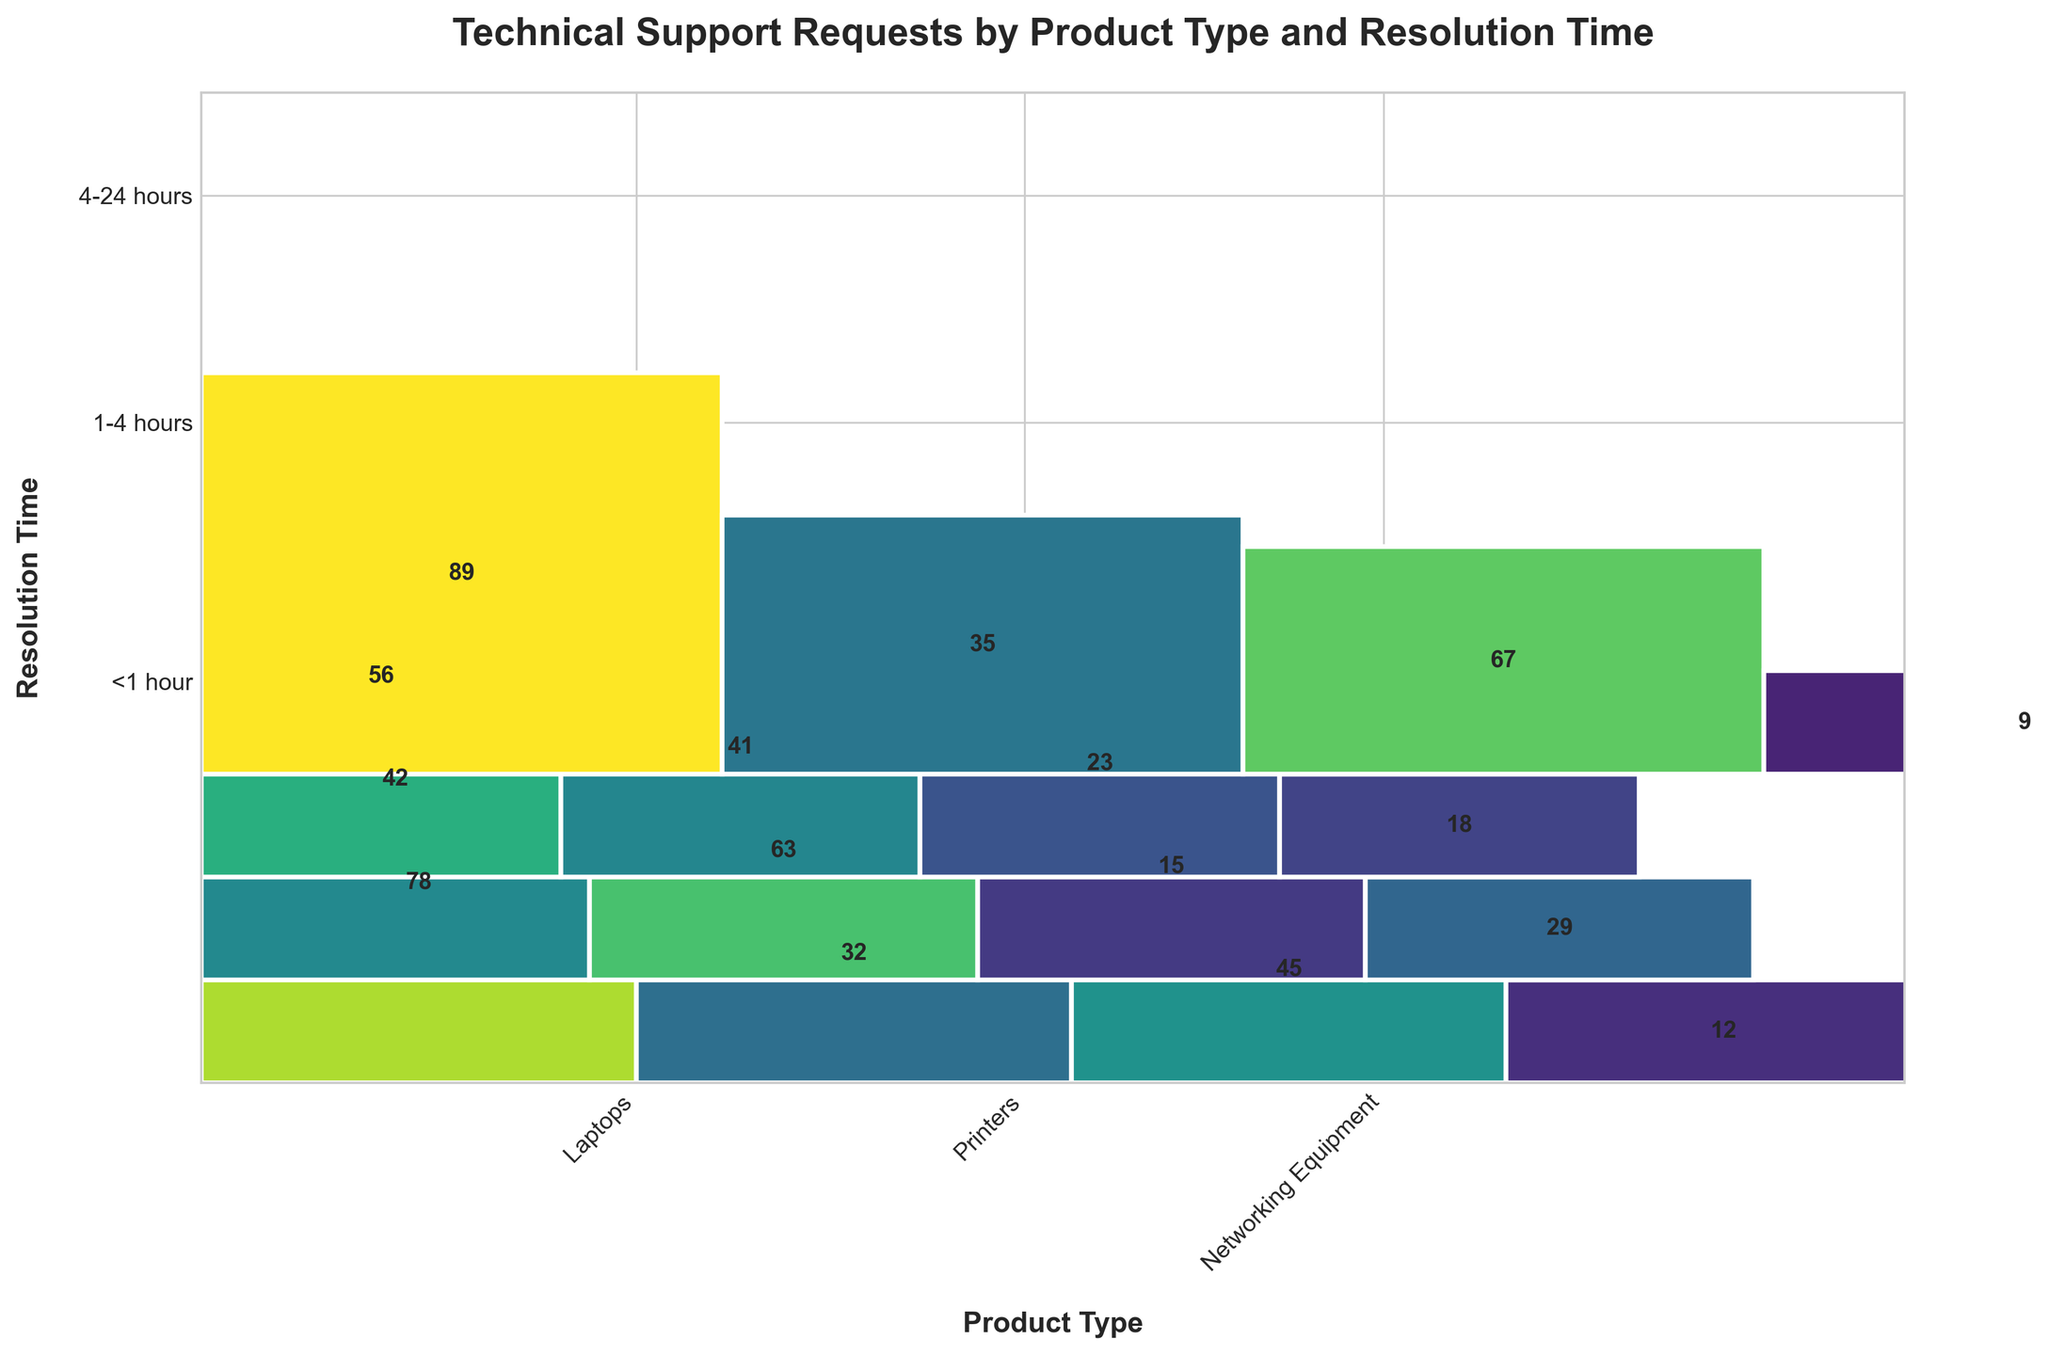What's the title of the plot? The title of the plot is given at the top of the figure. It is written in a larger and bolder font compared to other text elements. The title summarizes the content of the plot.
Answer: Technical Support Requests by Product Type and Resolution Time How many product types are represented in the plot? The product types can be identified by the different tick labels on the x-axis. Counting the unique labels will give the number of product types.
Answer: 4 Which resolution time category had the highest count for Software? Identify the rectangle corresponding to Software and compare its counts across different resolution times. The count values are written inside the rectangles.
Answer: 1-4 hours Which product had the fewest requests resolved within 1 hour? Look at the rectangles for each product type in the <1 hour category and read the counts. Find the smallest number.
Answer: Networking Equipment What is the total number of support requests for Printers? Add up the counts of all resolution times for Printers.
Answer: 138 Which product has the widest columns on the x-axis? The width of the columns corresponds to the total number of requests for each product type. Identifying the widest columns will point to the product with the highest total requests.
Answer: Software Which resolution time category has the highest total support requests? Sum the counts across all product types for each resolution time category and identify which sum is the highest.
Answer: 1-4 hours Compare the count of requests for Laptops resolved in >24 hours to those for Networking Equipment in the same category. Which is higher? Find the rectangles for Laptops and Networking Equipment in the >24 hours category and compare their counts.
Answer: Networking Equipment Is there any product type with an even distribution of support requests across all resolution times? For an even distribution, the counts should be relatively similar across all resolution categories for a given product. Check the count values for each product type.
Answer: No Which product type had a significant number of requests resolved in less than 1 hour compared to other resolution times for the same product? Look for product types where the count in the <1 hour resolution time category is noticeably higher than in the other resolution time categories for the same product.
Answer: Software 